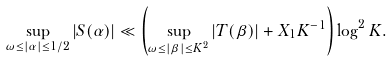Convert formula to latex. <formula><loc_0><loc_0><loc_500><loc_500>\sup _ { \omega \leq | \alpha | \leq 1 / 2 } | S ( \alpha ) | \ll \left ( \sup _ { \omega \leq | \beta | \leq K ^ { 2 } } | T ( \beta ) | + X _ { 1 } K ^ { - 1 } \right ) \log ^ { 2 } K .</formula> 